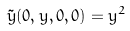Convert formula to latex. <formula><loc_0><loc_0><loc_500><loc_500>\tilde { y } ( 0 , y , 0 , 0 ) = y ^ { 2 }</formula> 